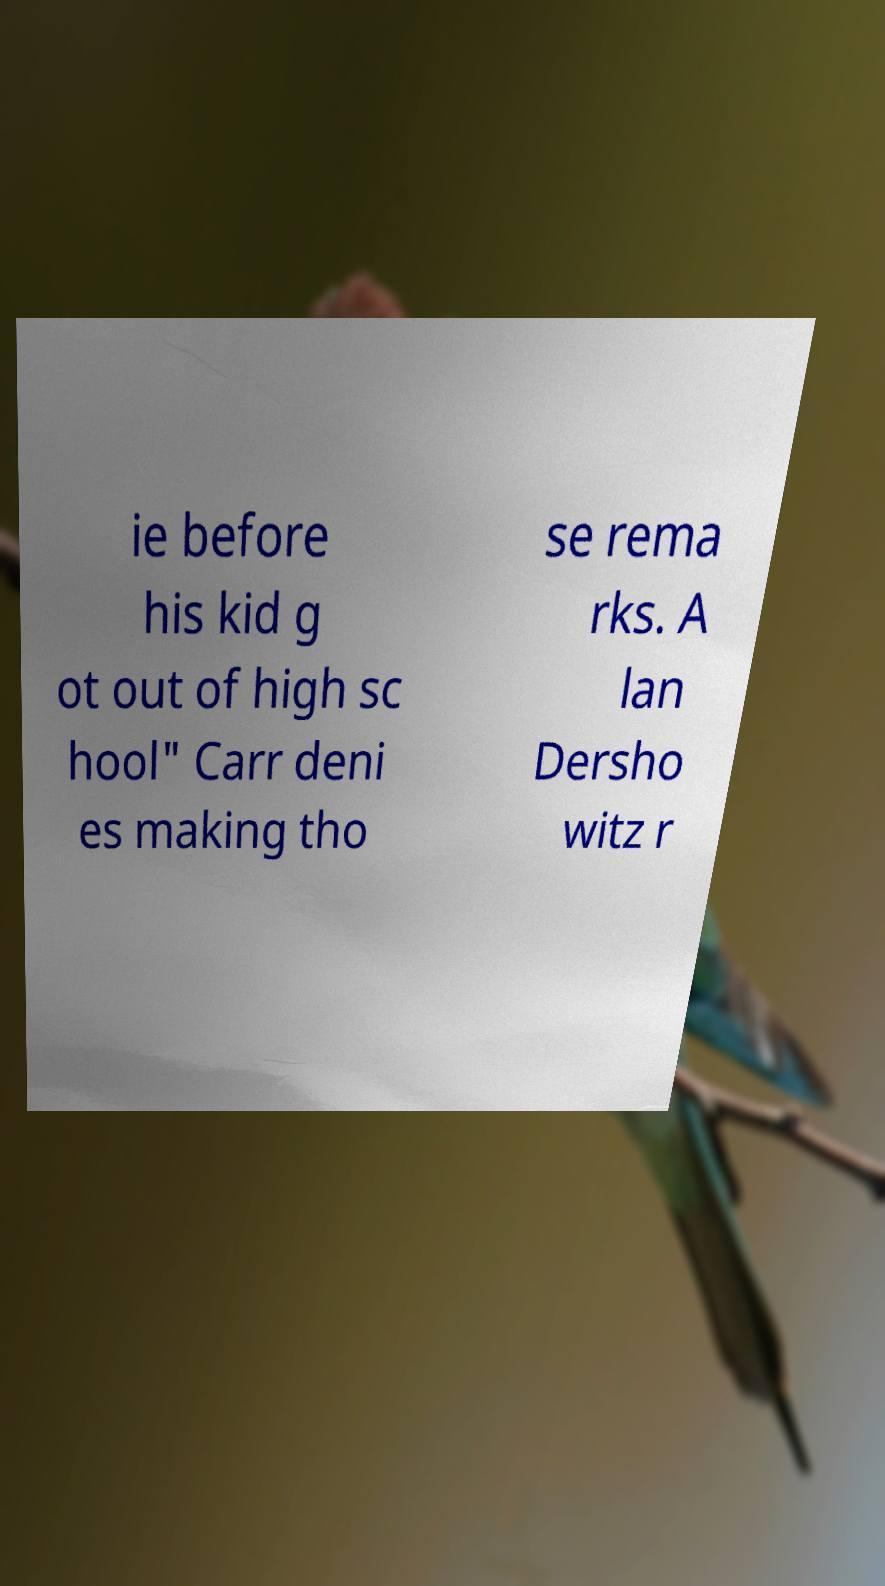Can you read and provide the text displayed in the image?This photo seems to have some interesting text. Can you extract and type it out for me? ie before his kid g ot out of high sc hool" Carr deni es making tho se rema rks. A lan Dersho witz r 